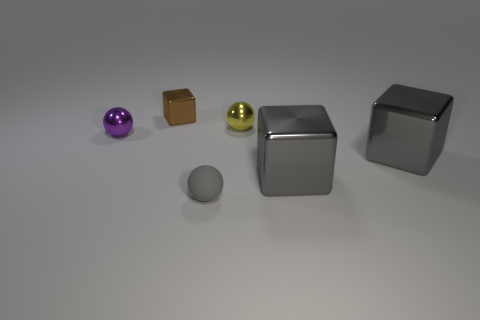There is a metallic ball to the right of the tiny metal cube; what color is it?
Make the answer very short. Yellow. What size is the brown thing that is made of the same material as the small purple object?
Offer a terse response. Small. What number of gray matte things have the same shape as the tiny purple shiny thing?
Keep it short and to the point. 1. There is a yellow thing that is the same size as the brown shiny block; what is it made of?
Provide a short and direct response. Metal. Are there any small blue things made of the same material as the gray ball?
Provide a succinct answer. No. What color is the sphere that is behind the gray matte thing and right of the small purple object?
Keep it short and to the point. Yellow. How many other things are the same color as the small metallic block?
Provide a succinct answer. 0. There is a yellow ball that is on the right side of the small sphere that is in front of the small metallic ball on the left side of the small brown cube; what is its material?
Your answer should be compact. Metal. What number of balls are either rubber objects or large brown shiny objects?
Offer a very short reply. 1. Is there any other thing that is the same size as the gray matte ball?
Your response must be concise. Yes. 